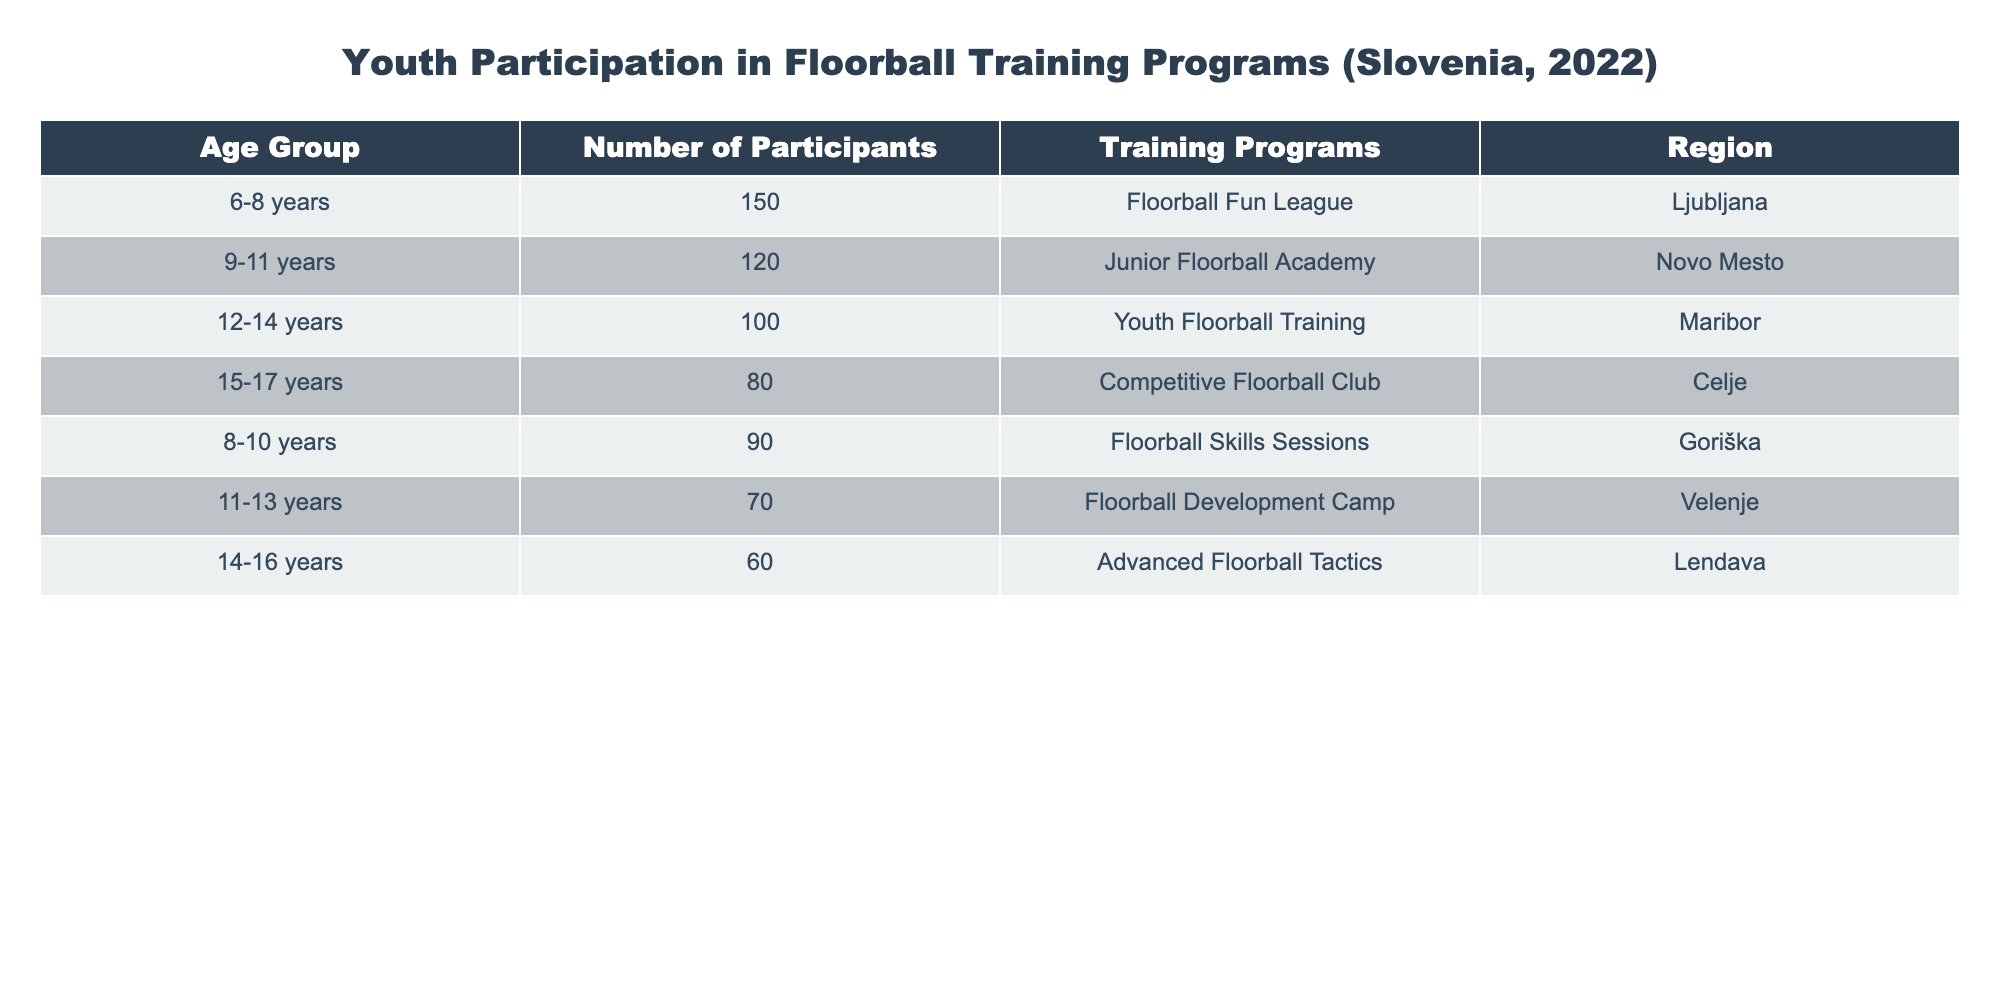What age group has the highest number of participants? The age group with the highest number of participants is 6-8 years with 150 participants, as seen in the first row of the table.
Answer: 6-8 years Which region has the most training programs available? Based on the table, all regions have at least one training program, but Ljubljana has one program, Novo Mesto has one, and so on, indicating that no region stands out with multiple programs. Therefore, all regions have the same number of training programs, which is one.
Answer: All regions have one program each What is the total number of participants across all age groups? Adding the number of participants from all age groups: 150 + 120 + 100 + 80 + 90 + 70 + 60 = 670 participants.
Answer: 670 Are there more participants aged 12-14 years than aged 14-16 years? According to the table, there are 100 participants aged 12-14 years and 60 participants aged 14-16 years. Since 100 is greater than 60, the statement is true.
Answer: True What is the average number of participants per training program? There are 7 training programs in total, with a combined participant count of 670. To find the average: 670 / 7 = approximately 95.71 participants per program.
Answer: Approximately 95.71 Which age group has the least number of participants? The age group with the least number of participants is 14-16 years with 60 participants, clearly denoted in the last row of the table.
Answer: 14-16 years Is the number of participants in the “Competitive Floorball Club” greater than the number of participants in the “Junior Floorball Academy”? The "Competitive Floorball Club" has 80 participants while the "Junior Floorball Academy" has 120 participants. Since 80 is less than 120, the statement is false.
Answer: False If we combine the participants from the two youngest age groups (6-8 and 8-10 years), how many participants would that total? The total would be 150 (6-8 years) + 90 (8-10 years) = 240 participants when combined.
Answer: 240 